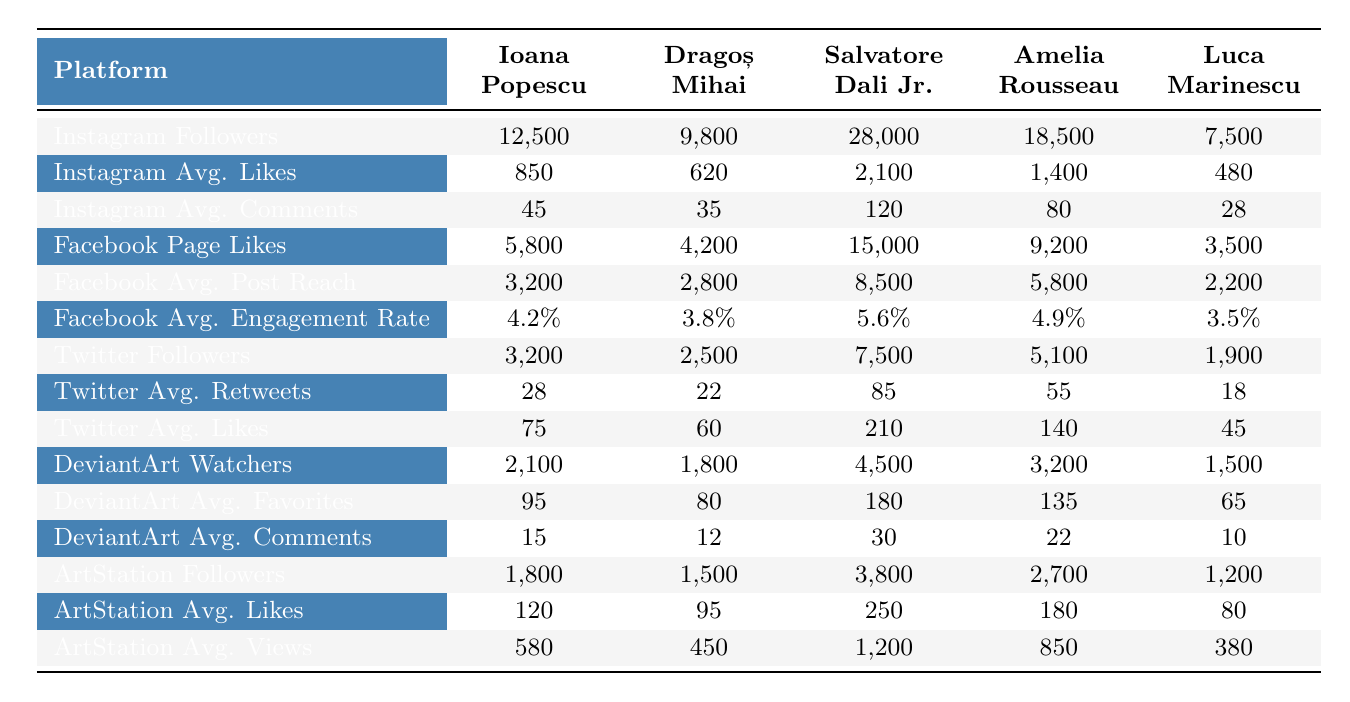What is the highest number of Instagram followers among the listed artists? By reviewing the Instagram follower counts in the table, Salvatore Dali Jr. has the most with 28,000 followers, while other artists have fewer.
Answer: 28,000 Which artist has the highest average engagement rate on Facebook? Looking at the Facebook average engagement rates, Salvatore Dali Jr. has the highest rate of 5.6%, which is greater than the rates of the other artists.
Answer: 5.6% What is the total number of Twitter followers for all listed artists? Summing up the Twitter followers: 3,200 + 2,500 + 7,500 + 5,100 + 1,900 = 20,200 gives the total number of Twitter followers.
Answer: 20,200 Who has the lowest average likes on Instagram? The table shows that Luca Marinescu has the lowest Instagram average likes at 480, compared to the others who have higher averages.
Answer: 480 What is the average number of DeviantArt watchers across all artists? Calculating the average involves summing the DeviantArt watchers: 2,100 + 1,800 + 4,500 + 3,200 + 1,500 = 13,100, then divide by the number of artists (5). 13,100 / 5 = 2,620 gives the average.
Answer: 2,620 Is it true that Amelia Rousseau has more Facebook page likes than Dragoș Mihai? By comparing the Facebook page likes from the table, Amelia Rousseau has 9,200 likes, while Dragoș Mihai has 4,200 likes, confirming the statement is true.
Answer: Yes Which artist has the most average likes on ArtStation? The highest average likes on ArtStation are from Salvatore Dali Jr. with 250 likes, more than the other artists listed.
Answer: 250 If we compare the total likes on Instagram for Ioana Popescu and Dragoș Mihai, whose total is higher? Ioana Popescu has 850 average likes and Dragoș Mihai has 620 average likes, but total likes would also depend on their total followers' count contextually. Without calculating post frequency, Ioana Popescu outperforms Dragoș Mihai in average likes.
Answer: Ioana Popescu What is the difference in average comments on Instagram between Salvatore Dali Jr. and Luca Marinescu? Salvatore Dali Jr. has 120 average comments on Instagram, and Luca Marinescu has 28. The difference is 120 - 28 = 92.
Answer: 92 Are the total DeviantArt favorites for all artists greater than 600? Adding the DeviantArt favorites gives: 95 + 80 + 180 + 135 + 65 = 555, which is less than 600, confirming the statement is false.
Answer: No Who has the highest average views on ArtStation? According to the table, Salvatore Dali Jr. leads with 1,200 average views, greater than those of the other artists.
Answer: 1,200 